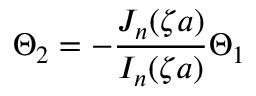Convert formula to latex. <formula><loc_0><loc_0><loc_500><loc_500>\Theta _ { 2 } = - \frac { J _ { n } ( \zeta a ) } { I _ { n } ( \zeta a ) } \Theta _ { 1 }</formula> 